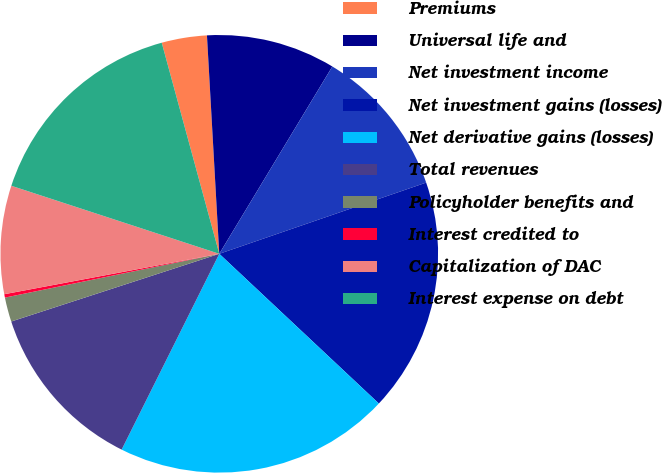Convert chart to OTSL. <chart><loc_0><loc_0><loc_500><loc_500><pie_chart><fcel>Premiums<fcel>Universal life and<fcel>Net investment income<fcel>Net investment gains (losses)<fcel>Net derivative gains (losses)<fcel>Total revenues<fcel>Policyholder benefits and<fcel>Interest credited to<fcel>Capitalization of DAC<fcel>Interest expense on debt<nl><fcel>3.34%<fcel>9.54%<fcel>11.08%<fcel>17.27%<fcel>20.37%<fcel>12.63%<fcel>1.8%<fcel>0.25%<fcel>7.99%<fcel>15.73%<nl></chart> 